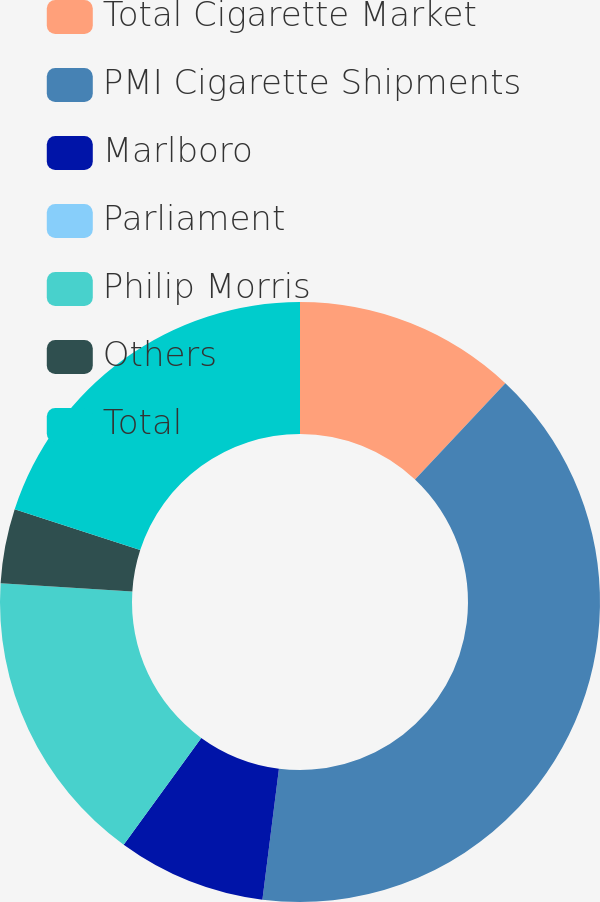<chart> <loc_0><loc_0><loc_500><loc_500><pie_chart><fcel>Total Cigarette Market<fcel>PMI Cigarette Shipments<fcel>Marlboro<fcel>Parliament<fcel>Philip Morris<fcel>Others<fcel>Total<nl><fcel>12.0%<fcel>40.0%<fcel>8.0%<fcel>0.0%<fcel>16.0%<fcel>4.0%<fcel>20.0%<nl></chart> 